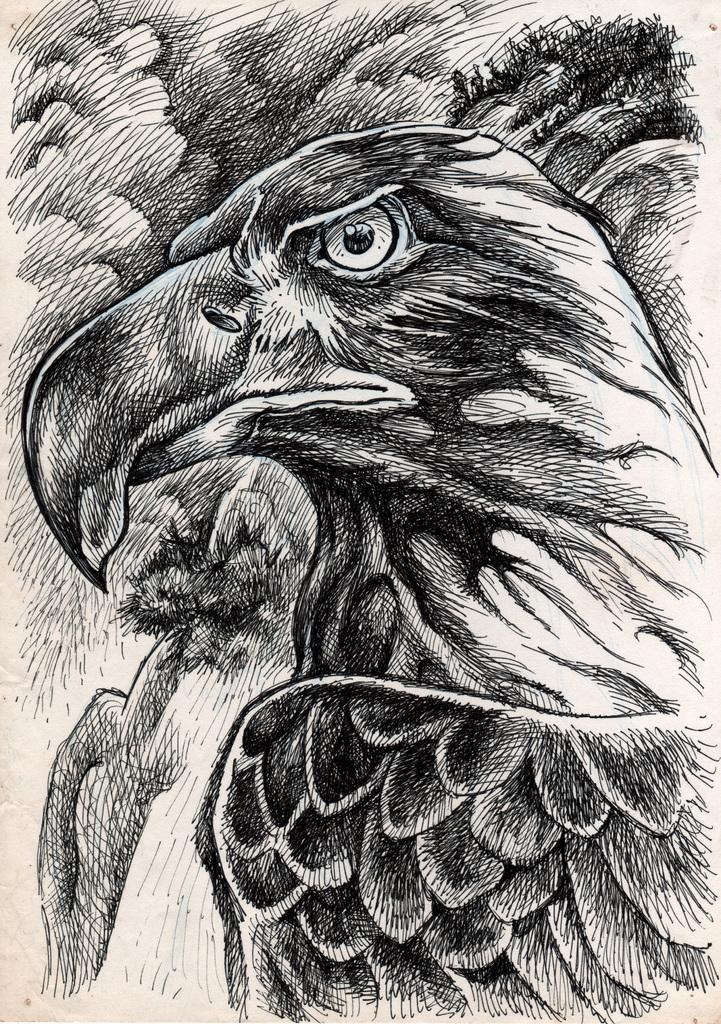What type of drawing is depicted in the image? The image contains a pencil sketch. What subject is featured in the sketch? There is a bird in the sketch. Can you identify the specific type of bird in the sketch? The bird appears to be an eagle. What color is the sofa in the image? There is no sofa present in the image; it features a pencil sketch of an eagle. How does the artist use a whistle while creating the sketch? There is no mention of a whistle in the image or the process of creating the sketch. 